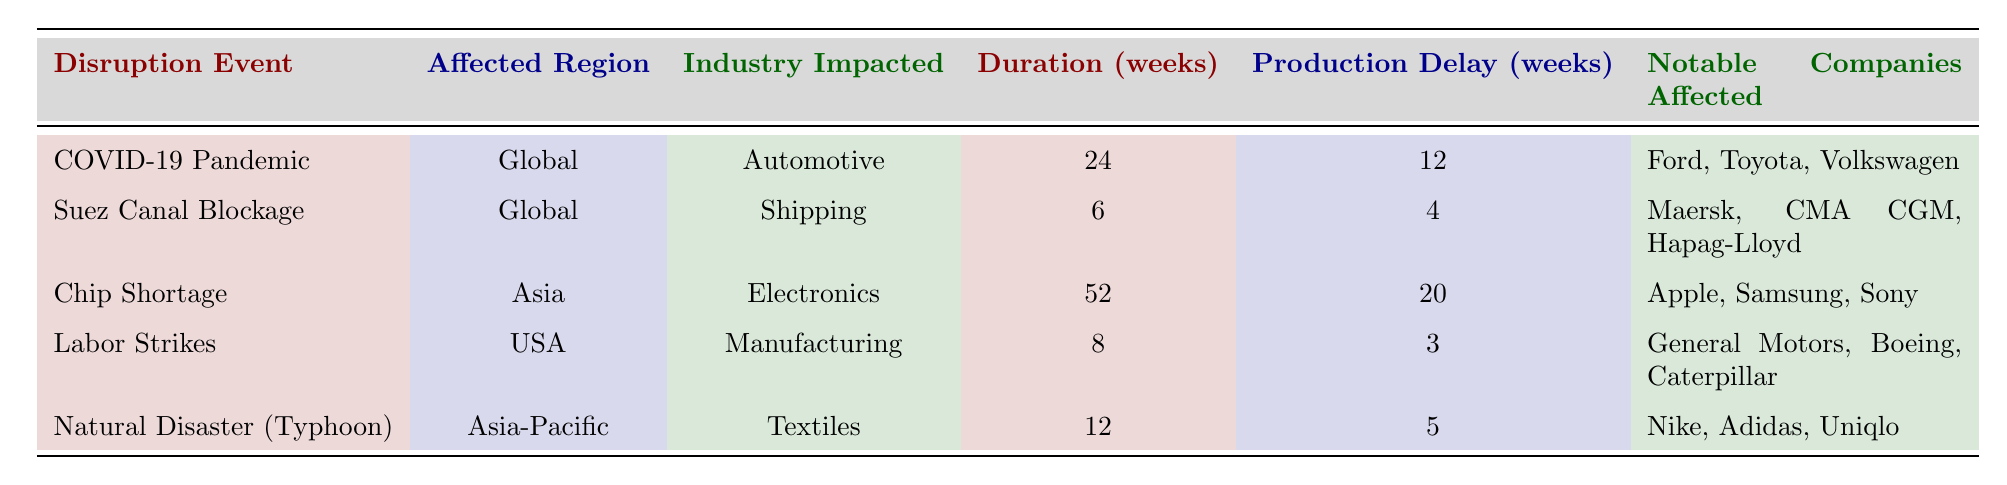What is the duration of the Chip Shortage disruption event? The duration of the Chip Shortage disruption event is listed in the table under the "Duration (weeks)" column, which shows a value of 52 weeks.
Answer: 52 weeks Which industry was impacted the longest by a disruption event? To find the industry impacted the longest, we look for the maximum value in the "Duration (weeks)" column. The Chip Shortage has the highest duration of 52 weeks, impacting the Electronics industry.
Answer: Electronics Were any of the notable companies affected by the Suez Canal Blockage also affected by the COVID-19 Pandemic? The table lists notable companies affected by both disruption events. Notable companies for the Suez Canal Blockage are Maersk, CMA CGM, and Hapag-Lloyd, while Ford, Toyota, and Volkswagen are affected by COVID-19. Comparing both lists shows there are no overlapping companies.
Answer: No How many weeks of production delay occurred during the COVID-19 Pandemic? The production delay for the COVID-19 Pandemic is specified in the "Production Delay (weeks)" column, which indicates a delay of 12 weeks.
Answer: 12 weeks What is the total production delay from the Chip Shortage and Natural Disaster disruptions? To find the total production delay, we sum the production delays from these events. The Chip Shortage has a production delay of 20 weeks, and the Natural Disaster has a delay of 5 weeks. Therefore, the total is 20 + 5 = 25 weeks.
Answer: 25 weeks Which disruption event affected the most notable companies? To determine this, we count the number of notable companies listed for each disruption. The Chip Shortage affects 3 companies, Labor Strikes also affect 3 companies, and COVID-19 Pandemic affects 3 companies, while the others have fewer. Therefore, multiple events affect an equal number of companies.
Answer: Multiple events (Chip Shortage, Labor Strikes, COVID-19 Pandemic) Is the Suez Canal Blockage more impactful in terms of duration or production delay than Labor Strikes? The Suez Canal Blockage has a duration of 6 weeks and a production delay of 4 weeks, while Labor Strikes have a duration of 8 weeks and a production delay of 3 weeks. Comparing both durability metrics shows the Suez Canal Blockage has shorter duration but higher production delay, though it has less impact overall due to shorter duration. Thus, the Suez Canal Blockage is less impactful in overall terms.
Answer: No Which affected region has the longest disruption duration according to the table? The affected region with the longest disruption is found by looking at all entries in the "Duration (weeks)" column. The Chip Shortage, which affects Asia, has the longest duration of 52 weeks.
Answer: Asia 